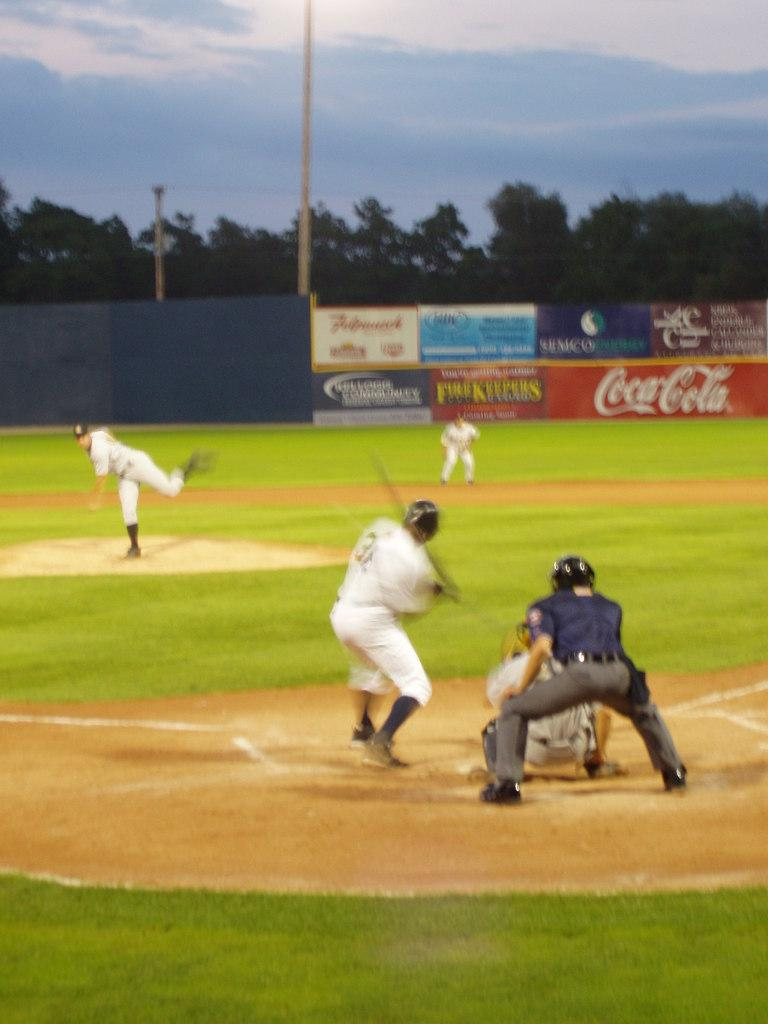What are the persons in the image doing? The persons in the image are playing a game on the ground. What can be seen in the sky in the image? The sky is visible at the top of the image. What type of vegetation is present in the image? There is a tree in the image. What structures can be seen in the image? There is a pole and a fence in the image. What type of cord is being used to tie the tree to the pole in the image? There is no cord present in the image, nor is the tree tied to the pole. 